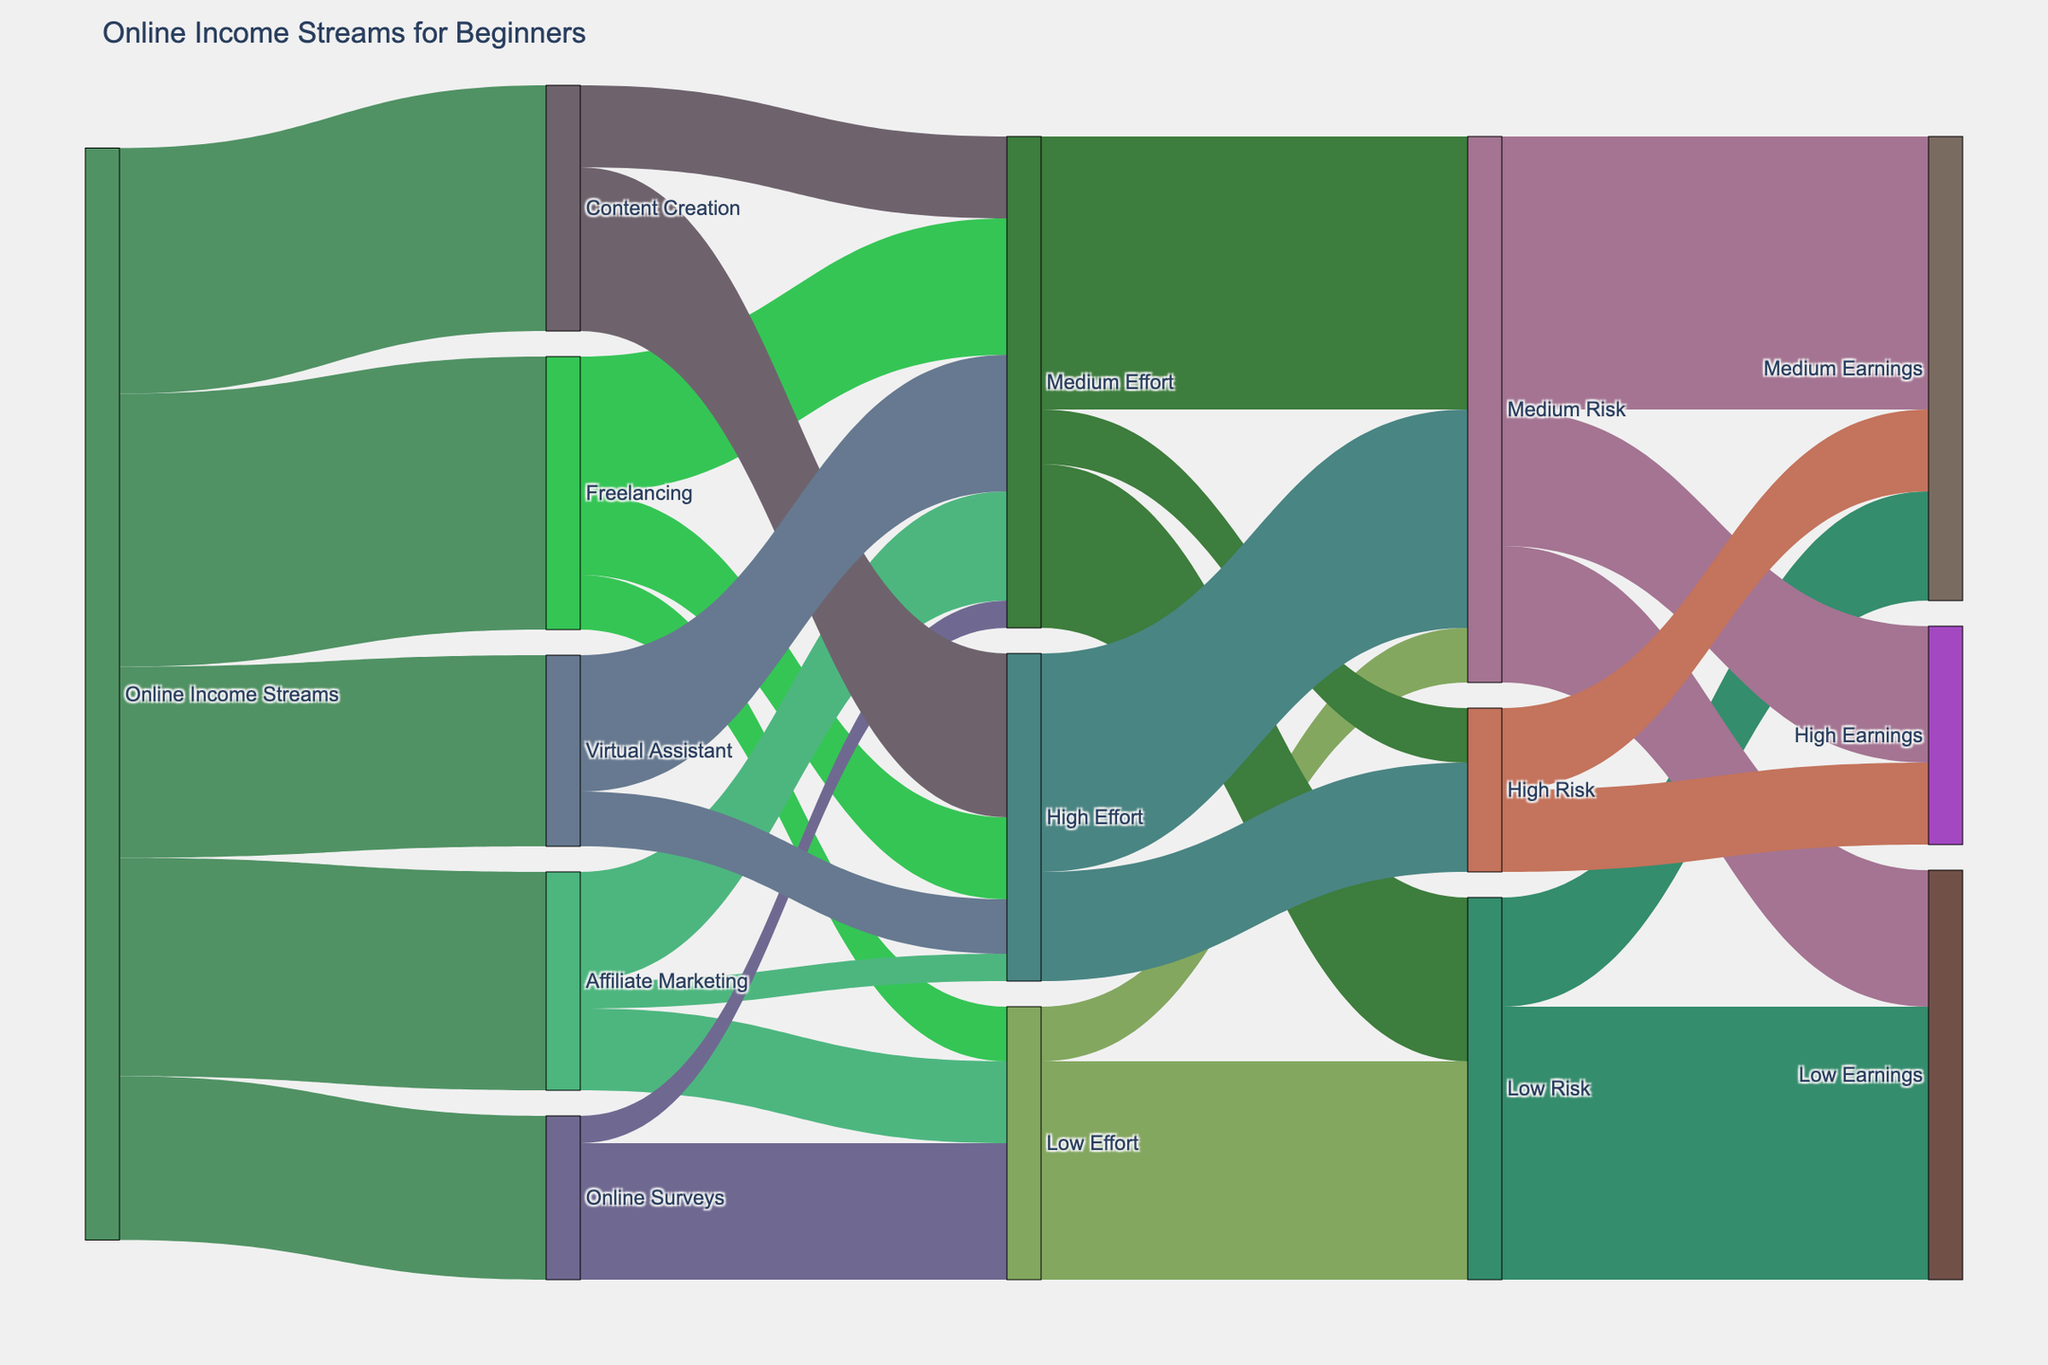What's the title of the diagram? The title of the diagram is typically displayed prominently at the top of the chart.
Answer: Online Income Streams for Beginners Which online income stream requires the most effort? To find the online income stream with the highest effort, look at the largest value flowing into the "High Effort" node.
Answer: Content Creation Which income stream has the highest amount of low-effort tasks? Check the streams flowing into the "Low Effort" node and find the largest value.
Answer: Online Surveys Are there more low-risk or high-risk tasks associated with medium effort activities? Compare the values flowing from "Medium Effort" to "Low Risk" and "Medium Risk" against "Medium Effort" to "High Risk".
Answer: More medium risk tasks (100) than low risk (60) and high risk (20) Which category of earnings has the highest value for medium-risk tasks? Look at the connections from "Medium Risk" to various earnings categories and identify the highest value.
Answer: Medium Earnings What’s the total value of low-effort and medium-effort tasks with low risk? Add the values flowing from "Low Effort" to "Low Risk" and "Medium Effort" to "Low Risk".
Answer: 80 + 60 = 140 Which income stream offers a balance between low effort and medium earnings? Look for streams connected to both “Low Effort” and “Medium Earnings”.
Answer: Affiliate Marketing How does the potential earnings of low-risk tasks compare to medium-risk tasks? Sum the values going from "Low Risk" to all earnings categories and compare them to the sum of values from "Medium Risk" to all earnings categories.
Answer: Low-risk tasks total 140, while medium-risk tasks total 200 What is the proportion of high-effort tasks that are associated with high risk? Identify the value from "High Effort" to "High Risk" and divide it by the total high-effort tasks.
Answer: 40/110 Which income streams have both medium and high-effort tasks? Check the income streams with links to both "Medium Effort" and "High Effort" nodes.
Answer: Freelancing, Content Creation, Virtual Assistant 